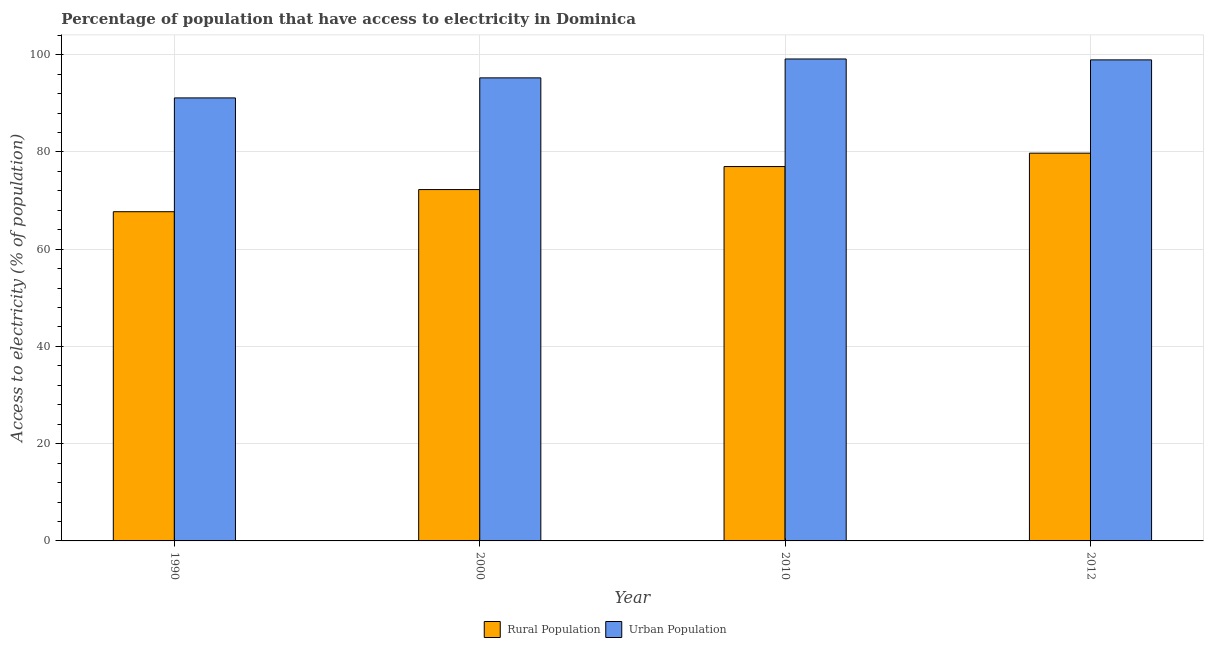Are the number of bars per tick equal to the number of legend labels?
Keep it short and to the point. Yes. How many bars are there on the 2nd tick from the left?
Keep it short and to the point. 2. How many bars are there on the 3rd tick from the right?
Keep it short and to the point. 2. What is the label of the 3rd group of bars from the left?
Keep it short and to the point. 2010. What is the percentage of rural population having access to electricity in 2000?
Offer a very short reply. 72.27. Across all years, what is the maximum percentage of rural population having access to electricity?
Give a very brief answer. 79.75. Across all years, what is the minimum percentage of urban population having access to electricity?
Make the answer very short. 91.12. In which year was the percentage of rural population having access to electricity maximum?
Offer a terse response. 2012. In which year was the percentage of rural population having access to electricity minimum?
Provide a short and direct response. 1990. What is the total percentage of urban population having access to electricity in the graph?
Make the answer very short. 384.43. What is the difference between the percentage of urban population having access to electricity in 1990 and that in 2000?
Ensure brevity in your answer.  -4.12. What is the difference between the percentage of rural population having access to electricity in 1990 and the percentage of urban population having access to electricity in 2010?
Keep it short and to the point. -9.29. What is the average percentage of urban population having access to electricity per year?
Your response must be concise. 96.11. In the year 2000, what is the difference between the percentage of rural population having access to electricity and percentage of urban population having access to electricity?
Offer a very short reply. 0. What is the ratio of the percentage of urban population having access to electricity in 1990 to that in 2010?
Ensure brevity in your answer.  0.92. Is the difference between the percentage of rural population having access to electricity in 2010 and 2012 greater than the difference between the percentage of urban population having access to electricity in 2010 and 2012?
Provide a short and direct response. No. What is the difference between the highest and the second highest percentage of urban population having access to electricity?
Offer a very short reply. 0.19. What is the difference between the highest and the lowest percentage of rural population having access to electricity?
Give a very brief answer. 12.04. What does the 1st bar from the left in 2012 represents?
Your answer should be very brief. Rural Population. What does the 1st bar from the right in 1990 represents?
Your answer should be very brief. Urban Population. Are all the bars in the graph horizontal?
Provide a short and direct response. No. How many years are there in the graph?
Your answer should be compact. 4. Does the graph contain any zero values?
Provide a succinct answer. No. How many legend labels are there?
Your response must be concise. 2. How are the legend labels stacked?
Your answer should be compact. Horizontal. What is the title of the graph?
Your response must be concise. Percentage of population that have access to electricity in Dominica. What is the label or title of the X-axis?
Ensure brevity in your answer.  Year. What is the label or title of the Y-axis?
Ensure brevity in your answer.  Access to electricity (% of population). What is the Access to electricity (% of population) of Rural Population in 1990?
Provide a short and direct response. 67.71. What is the Access to electricity (% of population) in Urban Population in 1990?
Give a very brief answer. 91.12. What is the Access to electricity (% of population) of Rural Population in 2000?
Offer a terse response. 72.27. What is the Access to electricity (% of population) in Urban Population in 2000?
Provide a short and direct response. 95.24. What is the Access to electricity (% of population) in Urban Population in 2010?
Offer a terse response. 99.13. What is the Access to electricity (% of population) of Rural Population in 2012?
Give a very brief answer. 79.75. What is the Access to electricity (% of population) in Urban Population in 2012?
Give a very brief answer. 98.94. Across all years, what is the maximum Access to electricity (% of population) of Rural Population?
Ensure brevity in your answer.  79.75. Across all years, what is the maximum Access to electricity (% of population) in Urban Population?
Make the answer very short. 99.13. Across all years, what is the minimum Access to electricity (% of population) in Rural Population?
Keep it short and to the point. 67.71. Across all years, what is the minimum Access to electricity (% of population) of Urban Population?
Provide a short and direct response. 91.12. What is the total Access to electricity (% of population) of Rural Population in the graph?
Make the answer very short. 296.73. What is the total Access to electricity (% of population) of Urban Population in the graph?
Make the answer very short. 384.43. What is the difference between the Access to electricity (% of population) of Rural Population in 1990 and that in 2000?
Your response must be concise. -4.55. What is the difference between the Access to electricity (% of population) in Urban Population in 1990 and that in 2000?
Provide a short and direct response. -4.12. What is the difference between the Access to electricity (% of population) in Rural Population in 1990 and that in 2010?
Your answer should be compact. -9.29. What is the difference between the Access to electricity (% of population) in Urban Population in 1990 and that in 2010?
Provide a succinct answer. -8.01. What is the difference between the Access to electricity (% of population) of Rural Population in 1990 and that in 2012?
Your answer should be very brief. -12.04. What is the difference between the Access to electricity (% of population) in Urban Population in 1990 and that in 2012?
Offer a terse response. -7.82. What is the difference between the Access to electricity (% of population) in Rural Population in 2000 and that in 2010?
Provide a short and direct response. -4.74. What is the difference between the Access to electricity (% of population) in Urban Population in 2000 and that in 2010?
Provide a succinct answer. -3.89. What is the difference between the Access to electricity (% of population) of Rural Population in 2000 and that in 2012?
Provide a short and direct response. -7.49. What is the difference between the Access to electricity (% of population) of Urban Population in 2000 and that in 2012?
Offer a terse response. -3.7. What is the difference between the Access to electricity (% of population) of Rural Population in 2010 and that in 2012?
Your answer should be very brief. -2.75. What is the difference between the Access to electricity (% of population) in Urban Population in 2010 and that in 2012?
Your answer should be very brief. 0.19. What is the difference between the Access to electricity (% of population) in Rural Population in 1990 and the Access to electricity (% of population) in Urban Population in 2000?
Give a very brief answer. -27.53. What is the difference between the Access to electricity (% of population) in Rural Population in 1990 and the Access to electricity (% of population) in Urban Population in 2010?
Give a very brief answer. -31.42. What is the difference between the Access to electricity (% of population) in Rural Population in 1990 and the Access to electricity (% of population) in Urban Population in 2012?
Keep it short and to the point. -31.23. What is the difference between the Access to electricity (% of population) of Rural Population in 2000 and the Access to electricity (% of population) of Urban Population in 2010?
Offer a terse response. -26.86. What is the difference between the Access to electricity (% of population) in Rural Population in 2000 and the Access to electricity (% of population) in Urban Population in 2012?
Provide a succinct answer. -26.68. What is the difference between the Access to electricity (% of population) in Rural Population in 2010 and the Access to electricity (% of population) in Urban Population in 2012?
Offer a terse response. -21.94. What is the average Access to electricity (% of population) in Rural Population per year?
Your answer should be compact. 74.18. What is the average Access to electricity (% of population) in Urban Population per year?
Offer a very short reply. 96.11. In the year 1990, what is the difference between the Access to electricity (% of population) in Rural Population and Access to electricity (% of population) in Urban Population?
Your answer should be compact. -23.41. In the year 2000, what is the difference between the Access to electricity (% of population) of Rural Population and Access to electricity (% of population) of Urban Population?
Make the answer very short. -22.98. In the year 2010, what is the difference between the Access to electricity (% of population) of Rural Population and Access to electricity (% of population) of Urban Population?
Make the answer very short. -22.13. In the year 2012, what is the difference between the Access to electricity (% of population) in Rural Population and Access to electricity (% of population) in Urban Population?
Provide a short and direct response. -19.19. What is the ratio of the Access to electricity (% of population) in Rural Population in 1990 to that in 2000?
Make the answer very short. 0.94. What is the ratio of the Access to electricity (% of population) in Urban Population in 1990 to that in 2000?
Provide a short and direct response. 0.96. What is the ratio of the Access to electricity (% of population) of Rural Population in 1990 to that in 2010?
Ensure brevity in your answer.  0.88. What is the ratio of the Access to electricity (% of population) in Urban Population in 1990 to that in 2010?
Keep it short and to the point. 0.92. What is the ratio of the Access to electricity (% of population) of Rural Population in 1990 to that in 2012?
Offer a terse response. 0.85. What is the ratio of the Access to electricity (% of population) of Urban Population in 1990 to that in 2012?
Give a very brief answer. 0.92. What is the ratio of the Access to electricity (% of population) of Rural Population in 2000 to that in 2010?
Provide a succinct answer. 0.94. What is the ratio of the Access to electricity (% of population) in Urban Population in 2000 to that in 2010?
Ensure brevity in your answer.  0.96. What is the ratio of the Access to electricity (% of population) of Rural Population in 2000 to that in 2012?
Give a very brief answer. 0.91. What is the ratio of the Access to electricity (% of population) of Urban Population in 2000 to that in 2012?
Ensure brevity in your answer.  0.96. What is the ratio of the Access to electricity (% of population) of Rural Population in 2010 to that in 2012?
Keep it short and to the point. 0.97. What is the difference between the highest and the second highest Access to electricity (% of population) in Rural Population?
Give a very brief answer. 2.75. What is the difference between the highest and the second highest Access to electricity (% of population) of Urban Population?
Provide a succinct answer. 0.19. What is the difference between the highest and the lowest Access to electricity (% of population) of Rural Population?
Your response must be concise. 12.04. What is the difference between the highest and the lowest Access to electricity (% of population) in Urban Population?
Your answer should be compact. 8.01. 